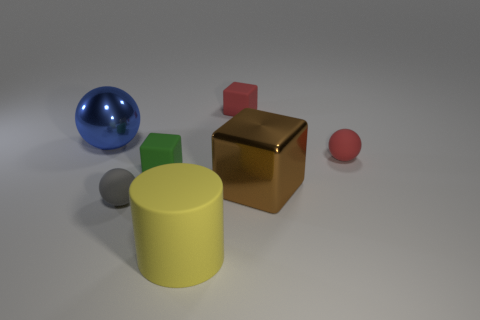The ball that is left of the tiny red sphere and in front of the large ball is what color?
Provide a short and direct response. Gray. Is the shape of the tiny thing behind the red rubber sphere the same as the small object in front of the big metallic block?
Give a very brief answer. No. There is a tiny cube that is to the right of the large matte object; what material is it?
Offer a terse response. Rubber. What number of objects are either spheres that are in front of the large metal cube or red blocks?
Your answer should be compact. 2. Are there an equal number of blue spheres on the right side of the brown thing and cylinders?
Keep it short and to the point. No. Is the size of the red matte block the same as the brown object?
Your response must be concise. No. There is a block that is the same size as the green object; what color is it?
Give a very brief answer. Red. There is a blue metal object; is it the same size as the metallic thing on the right side of the blue metal sphere?
Give a very brief answer. Yes. How many things are tiny red spheres or small matte things that are right of the cylinder?
Make the answer very short. 2. Is the size of the red thing that is behind the big metallic ball the same as the metal object left of the yellow matte thing?
Ensure brevity in your answer.  No. 